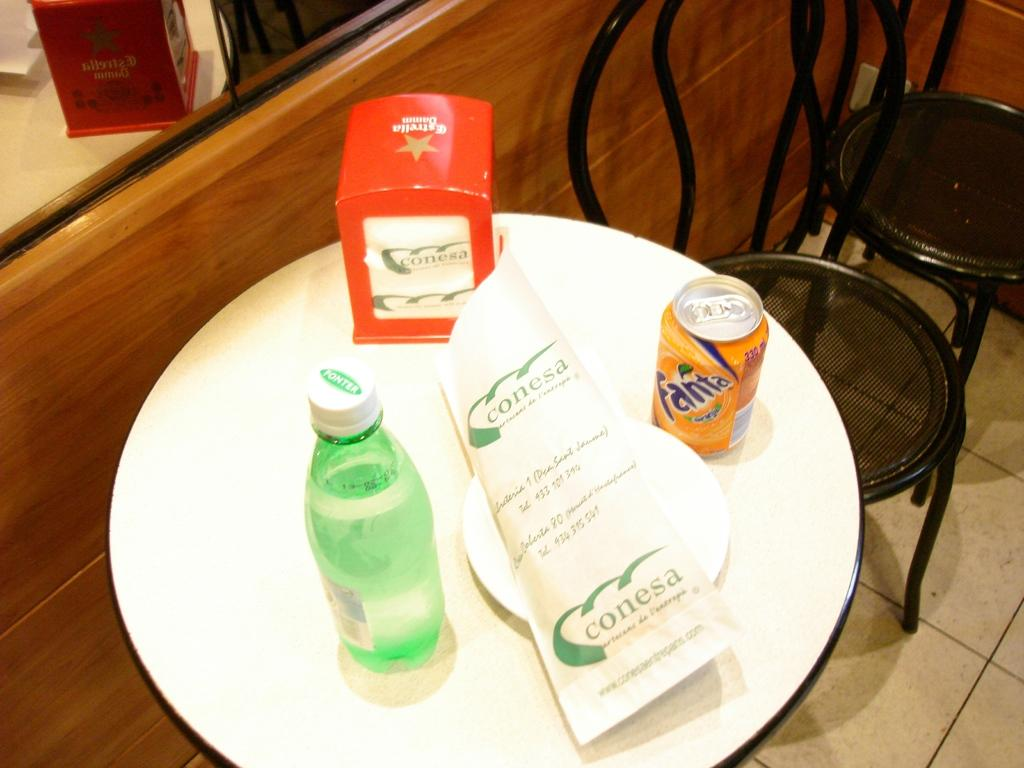<image>
Provide a brief description of the given image. a can of orange fanta on a small white table 